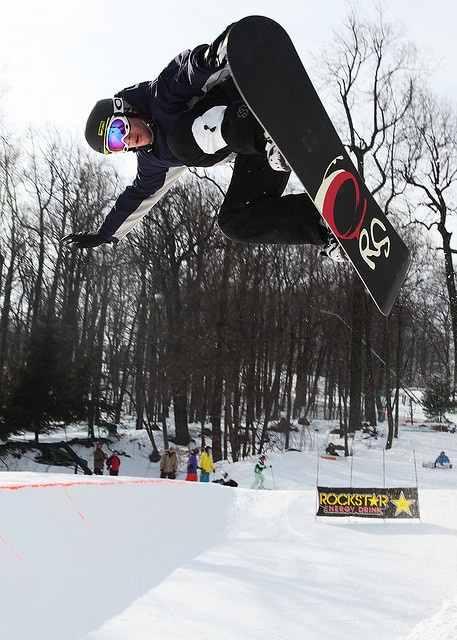Describe the objects in this image and their specific colors. I can see people in white, black, lightgray, gray, and darkgray tones, snowboard in white, black, lightgray, gray, and darkgray tones, people in white, gray, and black tones, people in white, olive, gold, blue, and black tones, and people in white, black, gray, and maroon tones in this image. 